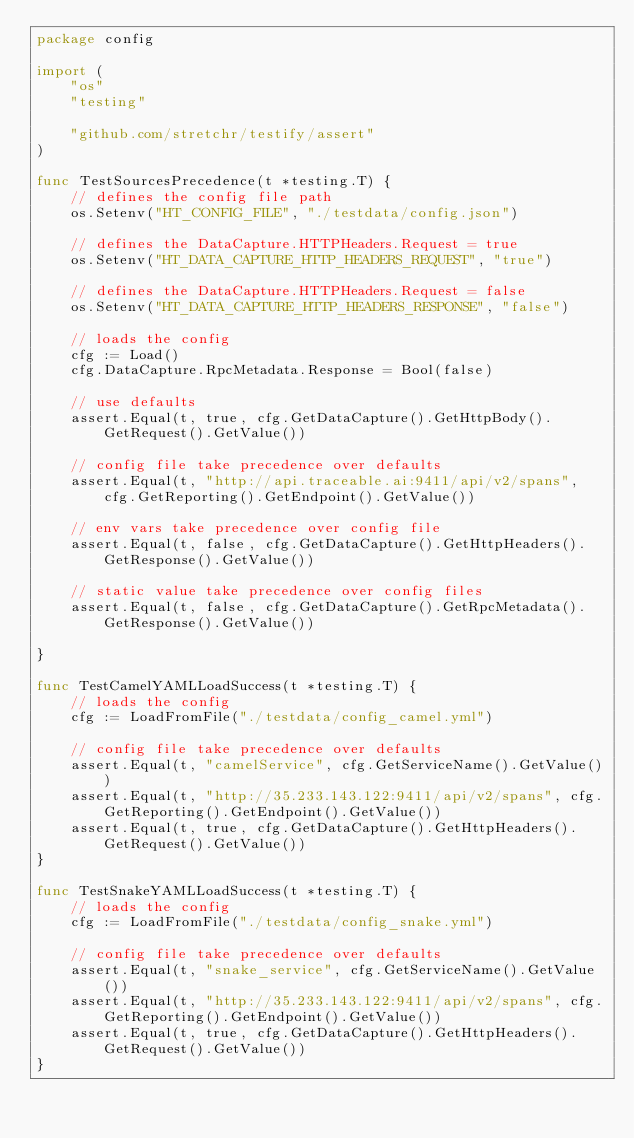Convert code to text. <code><loc_0><loc_0><loc_500><loc_500><_Go_>package config

import (
	"os"
	"testing"

	"github.com/stretchr/testify/assert"
)

func TestSourcesPrecedence(t *testing.T) {
	// defines the config file path
	os.Setenv("HT_CONFIG_FILE", "./testdata/config.json")

	// defines the DataCapture.HTTPHeaders.Request = true
	os.Setenv("HT_DATA_CAPTURE_HTTP_HEADERS_REQUEST", "true")

	// defines the DataCapture.HTTPHeaders.Request = false
	os.Setenv("HT_DATA_CAPTURE_HTTP_HEADERS_RESPONSE", "false")

	// loads the config
	cfg := Load()
	cfg.DataCapture.RpcMetadata.Response = Bool(false)

	// use defaults
	assert.Equal(t, true, cfg.GetDataCapture().GetHttpBody().GetRequest().GetValue())

	// config file take precedence over defaults
	assert.Equal(t, "http://api.traceable.ai:9411/api/v2/spans", cfg.GetReporting().GetEndpoint().GetValue())

	// env vars take precedence over config file
	assert.Equal(t, false, cfg.GetDataCapture().GetHttpHeaders().GetResponse().GetValue())

	// static value take precedence over config files
	assert.Equal(t, false, cfg.GetDataCapture().GetRpcMetadata().GetResponse().GetValue())

}

func TestCamelYAMLLoadSuccess(t *testing.T) {
	// loads the config
	cfg := LoadFromFile("./testdata/config_camel.yml")

	// config file take precedence over defaults
	assert.Equal(t, "camelService", cfg.GetServiceName().GetValue())
	assert.Equal(t, "http://35.233.143.122:9411/api/v2/spans", cfg.GetReporting().GetEndpoint().GetValue())
	assert.Equal(t, true, cfg.GetDataCapture().GetHttpHeaders().GetRequest().GetValue())
}

func TestSnakeYAMLLoadSuccess(t *testing.T) {
	// loads the config
	cfg := LoadFromFile("./testdata/config_snake.yml")

	// config file take precedence over defaults
	assert.Equal(t, "snake_service", cfg.GetServiceName().GetValue())
	assert.Equal(t, "http://35.233.143.122:9411/api/v2/spans", cfg.GetReporting().GetEndpoint().GetValue())
	assert.Equal(t, true, cfg.GetDataCapture().GetHttpHeaders().GetRequest().GetValue())
}
</code> 